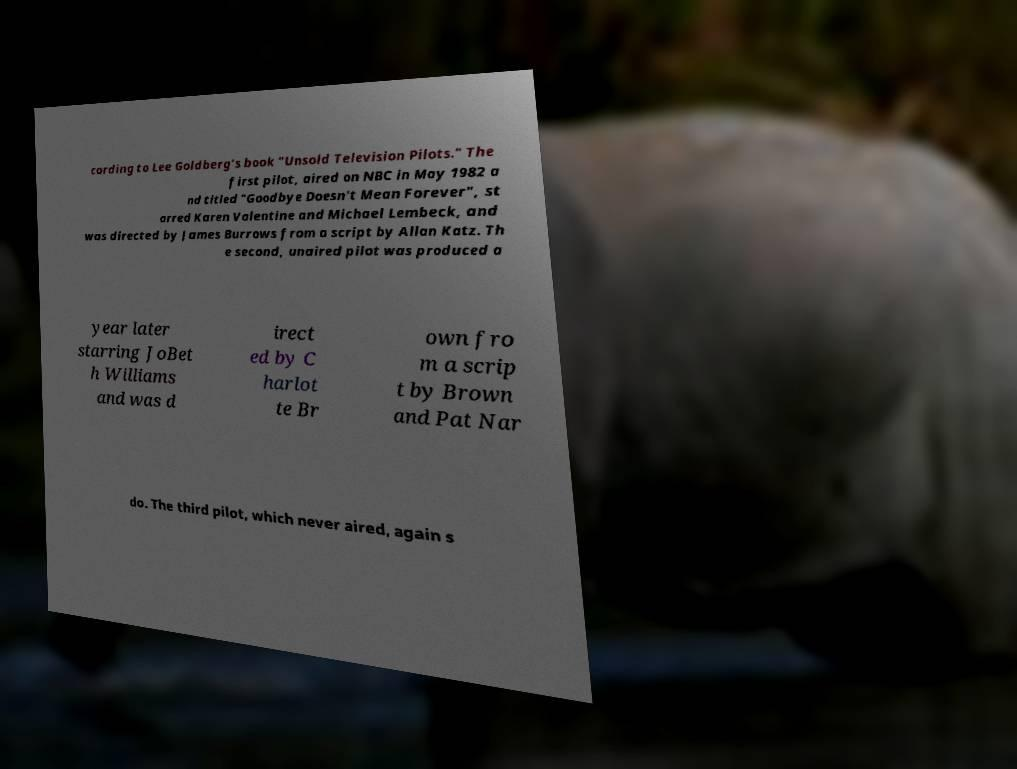What messages or text are displayed in this image? I need them in a readable, typed format. cording to Lee Goldberg's book "Unsold Television Pilots." The first pilot, aired on NBC in May 1982 a nd titled "Goodbye Doesn't Mean Forever", st arred Karen Valentine and Michael Lembeck, and was directed by James Burrows from a script by Allan Katz. Th e second, unaired pilot was produced a year later starring JoBet h Williams and was d irect ed by C harlot te Br own fro m a scrip t by Brown and Pat Nar do. The third pilot, which never aired, again s 